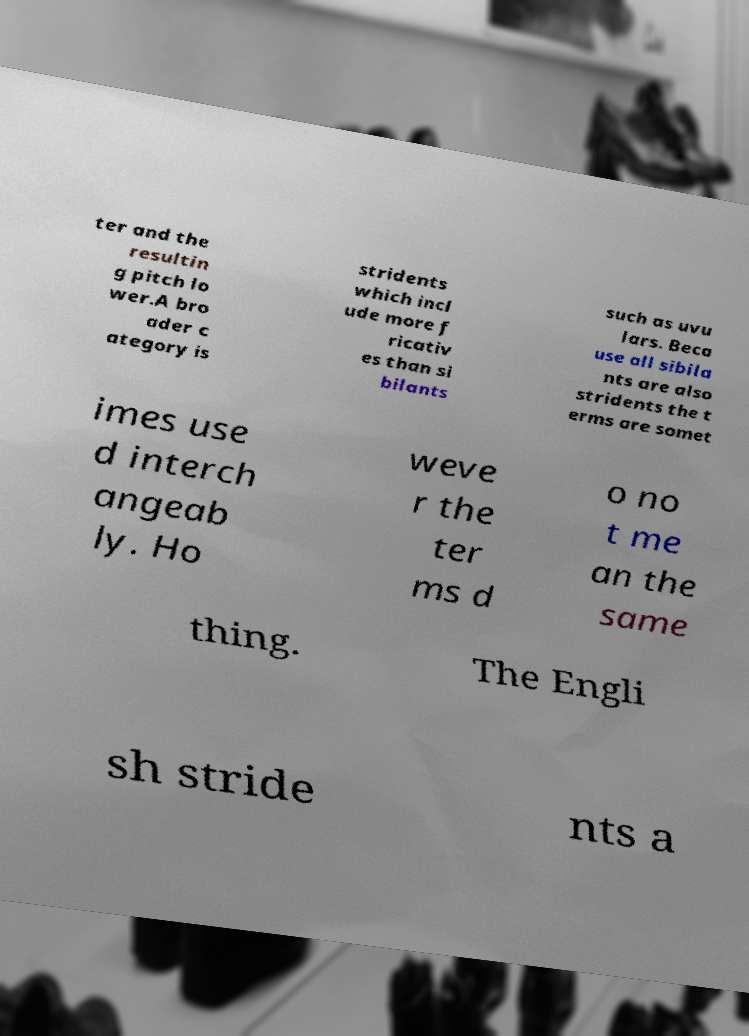What messages or text are displayed in this image? I need them in a readable, typed format. ter and the resultin g pitch lo wer.A bro ader c ategory is stridents which incl ude more f ricativ es than si bilants such as uvu lars. Beca use all sibila nts are also stridents the t erms are somet imes use d interch angeab ly. Ho weve r the ter ms d o no t me an the same thing. The Engli sh stride nts a 